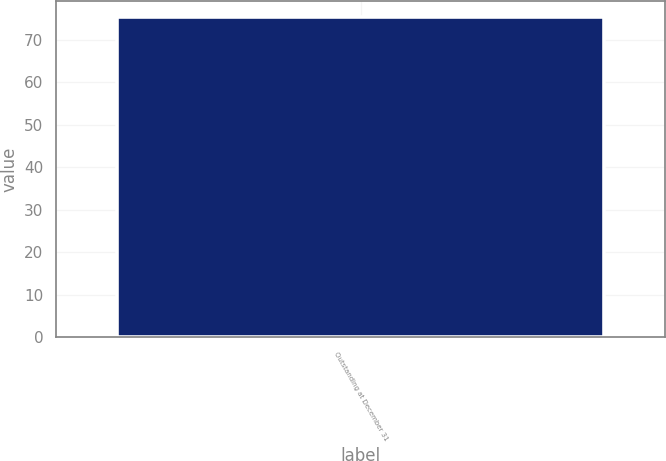Convert chart. <chart><loc_0><loc_0><loc_500><loc_500><bar_chart><fcel>Outstanding at December 31<nl><fcel>75.43<nl></chart> 